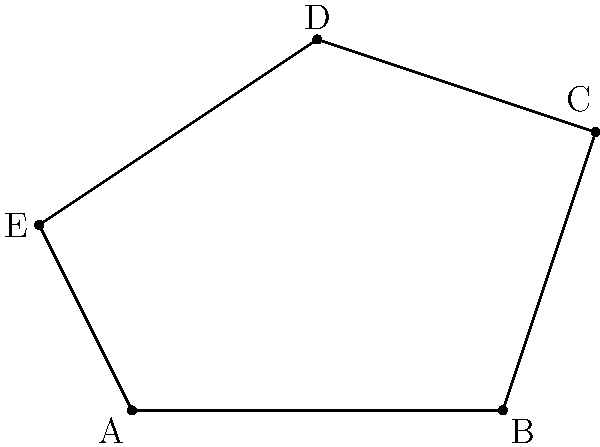In your research on geometric patterns in architectural designs, you've come across a unique pentagonal structure. The interior angles of this pentagon ABCDE are in arithmetic progression with a common difference of 9°. If the smallest interior angle is 93°, what is the measure of the largest exterior angle of this pentagon? Let's approach this step-by-step:

1) First, recall that the sum of interior angles of a pentagon is $(n-2) \times 180°$, where $n=5$. So, $\sum_{interior} = 540°$

2) Let the interior angles be $93°, 102°, 111°, 120°,$ and $129°$ (in arithmetic progression with common difference 9°)

3) We can verify: $93° + 102° + 111° + 120° + 129° = 555° = 540°$

4) The largest exterior angle corresponds to the smallest interior angle. Recall that an exterior angle and its corresponding interior angle are supplementary, i.e., they sum to 180°.

5) So, the largest exterior angle = $180° - 93° = 87°$

This approach demonstrates how to use properties of polygons and angle relationships to solve complex geometric problems, which is crucial for analyzing architectural designs in journalism.
Answer: 87° 